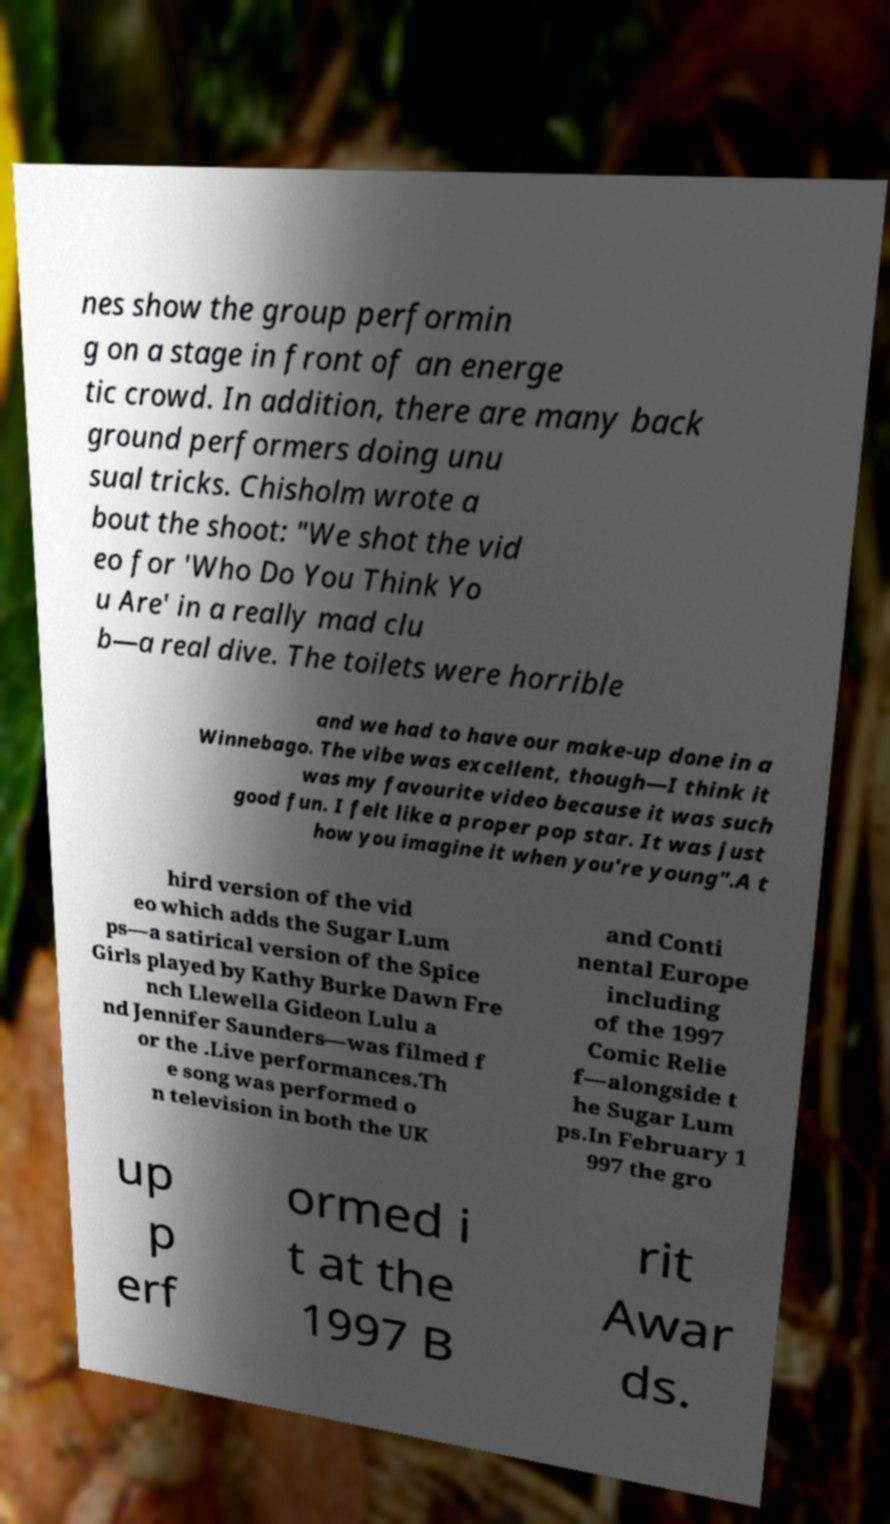Could you assist in decoding the text presented in this image and type it out clearly? nes show the group performin g on a stage in front of an energe tic crowd. In addition, there are many back ground performers doing unu sual tricks. Chisholm wrote a bout the shoot: "We shot the vid eo for 'Who Do You Think Yo u Are' in a really mad clu b—a real dive. The toilets were horrible and we had to have our make-up done in a Winnebago. The vibe was excellent, though—I think it was my favourite video because it was such good fun. I felt like a proper pop star. It was just how you imagine it when you're young".A t hird version of the vid eo which adds the Sugar Lum ps—a satirical version of the Spice Girls played by Kathy Burke Dawn Fre nch Llewella Gideon Lulu a nd Jennifer Saunders—was filmed f or the .Live performances.Th e song was performed o n television in both the UK and Conti nental Europe including of the 1997 Comic Relie f—alongside t he Sugar Lum ps.In February 1 997 the gro up p erf ormed i t at the 1997 B rit Awar ds. 